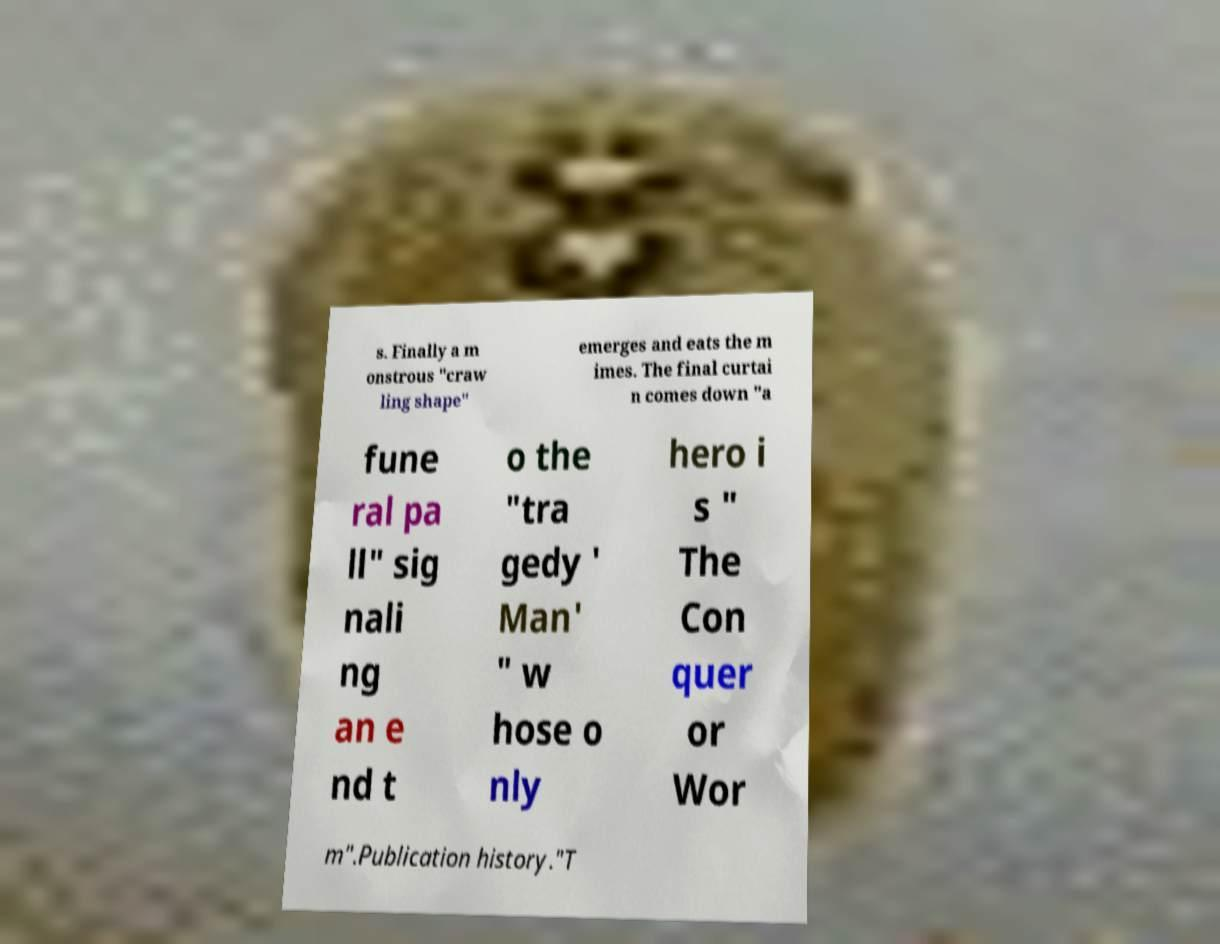Please identify and transcribe the text found in this image. s. Finally a m onstrous "craw ling shape" emerges and eats the m imes. The final curtai n comes down "a fune ral pa ll" sig nali ng an e nd t o the "tra gedy ' Man' " w hose o nly hero i s " The Con quer or Wor m".Publication history."T 